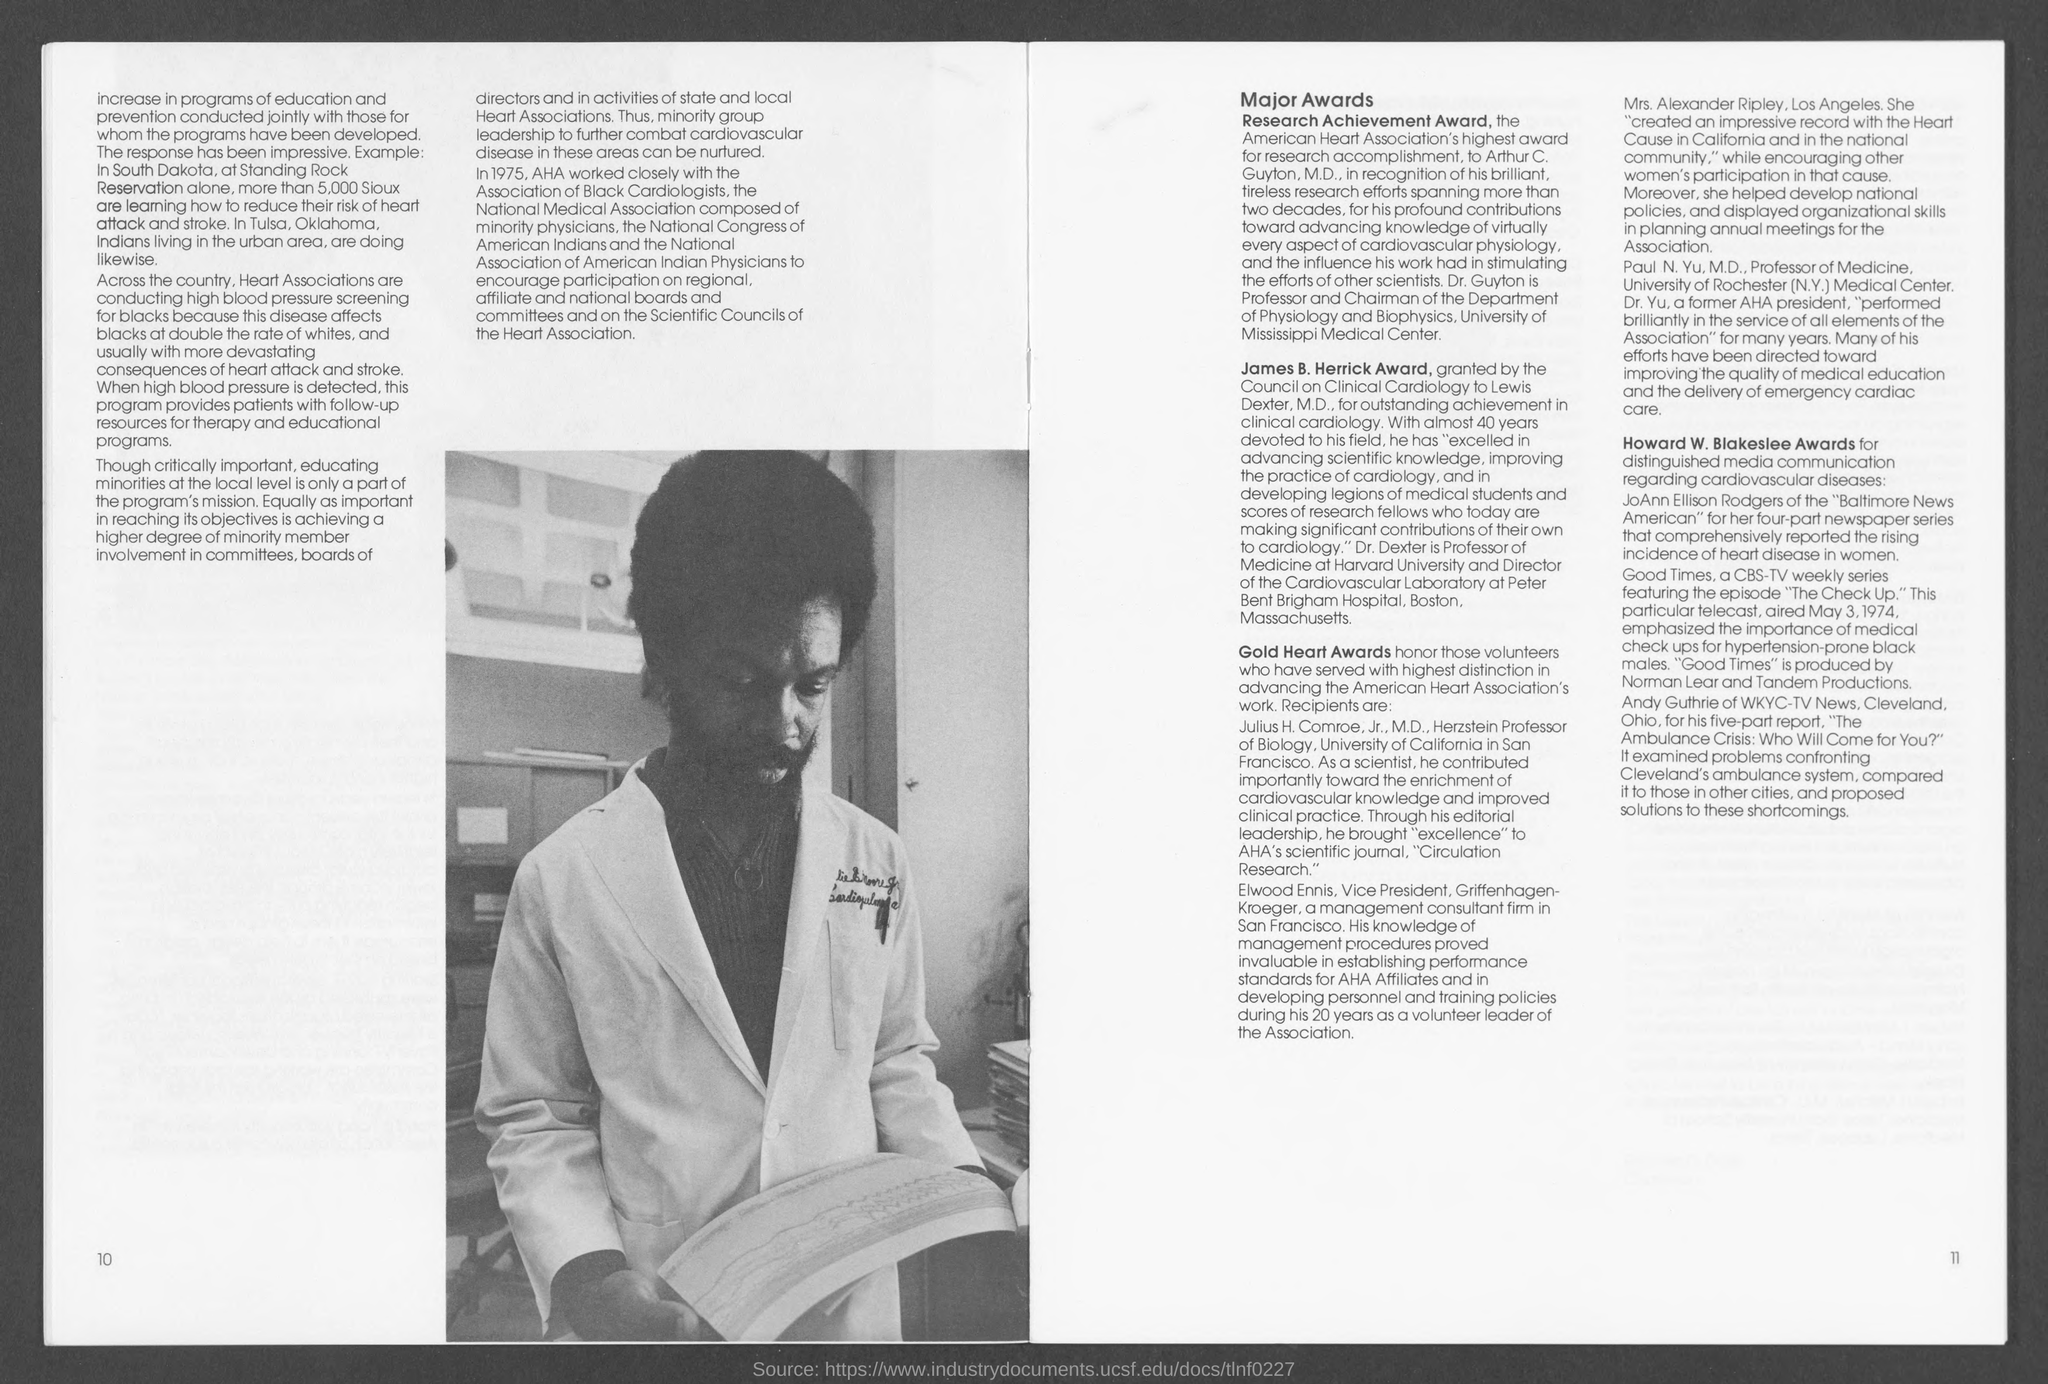Outline some significant characteristics in this image. The Howard W. Blakeslee Award is granted for outstanding achievement in media communication regarding cardiovascular diseases. The Gold Heart Awards are presented to volunteers who have demonstrated exceptional dedication and distinction in advancing the work of the American Heart Association. Julius H. Comroe, Jr., M.D., is the Herzstein Professor of Biology at the University of California in San Francisco. Dr. Arthur C. Guyton, a renowned Professor and Chairman of the Department of Physiology and Biophysics at the University of Mississippi Medical Center, has been designated as an expert in the field of physiology and biophysics. Mrs. Alexander Ripley has established an impressive record in the fight against the Heart Cause both in California and nationally. 